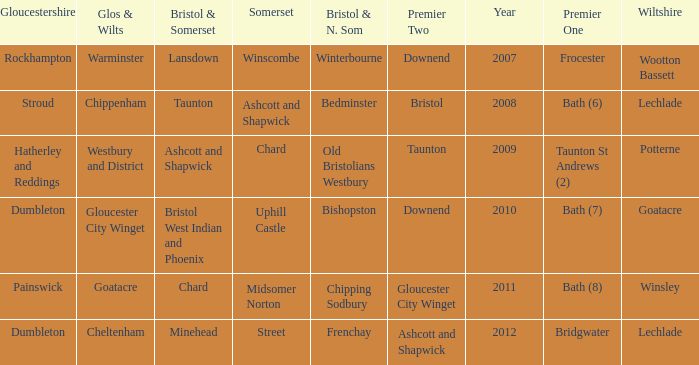What is the somerset for the  year 2009? Chard. 